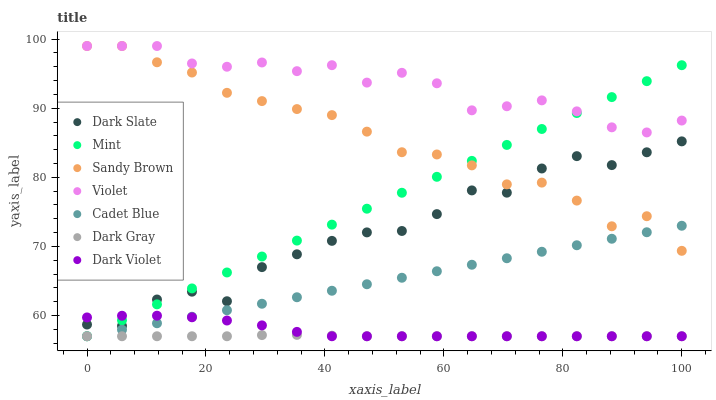Does Dark Gray have the minimum area under the curve?
Answer yes or no. Yes. Does Violet have the maximum area under the curve?
Answer yes or no. Yes. Does Sandy Brown have the minimum area under the curve?
Answer yes or no. No. Does Sandy Brown have the maximum area under the curve?
Answer yes or no. No. Is Mint the smoothest?
Answer yes or no. Yes. Is Dark Slate the roughest?
Answer yes or no. Yes. Is Sandy Brown the smoothest?
Answer yes or no. No. Is Sandy Brown the roughest?
Answer yes or no. No. Does Cadet Blue have the lowest value?
Answer yes or no. Yes. Does Sandy Brown have the lowest value?
Answer yes or no. No. Does Violet have the highest value?
Answer yes or no. Yes. Does Dark Violet have the highest value?
Answer yes or no. No. Is Dark Violet less than Violet?
Answer yes or no. Yes. Is Violet greater than Dark Violet?
Answer yes or no. Yes. Does Sandy Brown intersect Violet?
Answer yes or no. Yes. Is Sandy Brown less than Violet?
Answer yes or no. No. Is Sandy Brown greater than Violet?
Answer yes or no. No. Does Dark Violet intersect Violet?
Answer yes or no. No. 